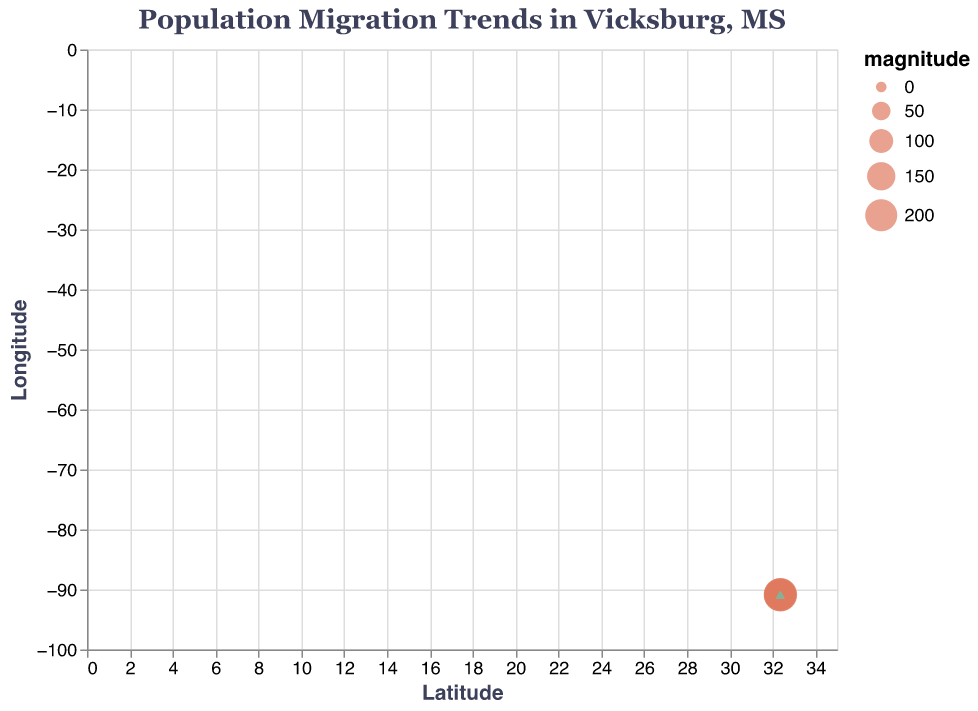What is the title of the quiver plot? The title is displayed at the top of the plot. It reads "Population Migration Trends in Vicksburg, MS".
Answer: Population Migration Trends in Vicksburg, MS How many data points are shown in the quiver plot? Count the number of distinct points on the plot.
Answer: 10 Which axis represents longitude, and which represents latitude? The x-axis represents latitude as indicated by its label, and the y-axis represents longitude as indicated by its label.
Answer: x-axis is latitude, y-axis is longitude What is the color of the points representing data? The points representing data are filled and colored, easily observable in the plot.
Answer: #E07A5F Which data point shows the largest migration magnitude, and what is its value? The size of the points in the plot varies based on the migration magnitude. Find the largest point. The magnitude is indicated in the dataset and reflected in the size of points.
Answer: 220 Which direction do most of the arrows point in terms of population movement? Observe the general direction of the arrows. The components (u, v) represent changes in latitude and longitude, respectively.
Answer: Towards the southeast Which data point has the largest vector magnitude, and what is its latitude and longitude? The largest vector magnitude corresponds to the largest circle. Check the dataset for the corresponding latitude and longitude values.
Answer: (32.3587, -90.8698) Which point shows a negative migration in both latitude and longitude? Negative u and negative v indicate a decrease in both latitude and longitude. Look for the point where both u and v are negative in the dataset.
Answer: (32.3503, -90.8856) How does the migration trend at the point with the largest vector magnitude compare to the average trend in latitude? First, find the average u (latitude change). Then compare it with the u of the point with the largest magnitude (32.3587, -90.8698).
Answer: Above average (0.3 vs. 0.15) Which point shows a movement of 0.3 units in latitude and 0.1 units in longitude? By examining the dataset, locate the point where u = 0.3 and v = 0.1.
Answer: (32.3572, -90.8731) 